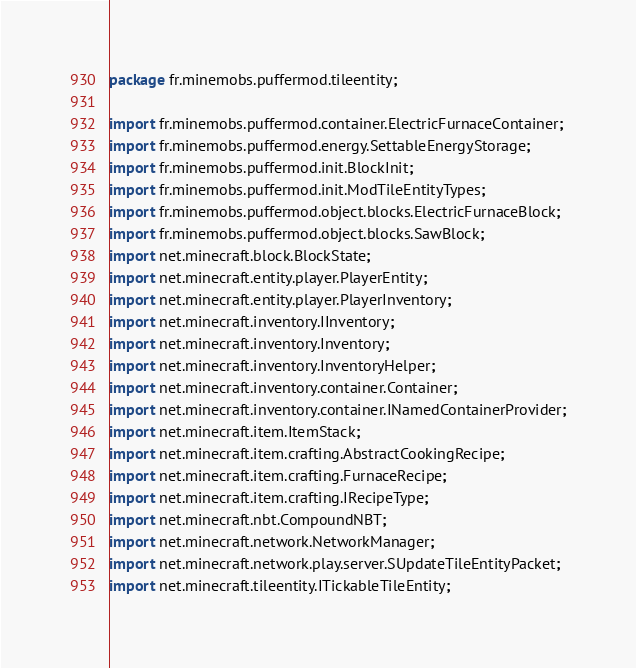<code> <loc_0><loc_0><loc_500><loc_500><_Java_>package fr.minemobs.puffermod.tileentity;

import fr.minemobs.puffermod.container.ElectricFurnaceContainer;
import fr.minemobs.puffermod.energy.SettableEnergyStorage;
import fr.minemobs.puffermod.init.BlockInit;
import fr.minemobs.puffermod.init.ModTileEntityTypes;
import fr.minemobs.puffermod.object.blocks.ElectricFurnaceBlock;
import fr.minemobs.puffermod.object.blocks.SawBlock;
import net.minecraft.block.BlockState;
import net.minecraft.entity.player.PlayerEntity;
import net.minecraft.entity.player.PlayerInventory;
import net.minecraft.inventory.IInventory;
import net.minecraft.inventory.Inventory;
import net.minecraft.inventory.InventoryHelper;
import net.minecraft.inventory.container.Container;
import net.minecraft.inventory.container.INamedContainerProvider;
import net.minecraft.item.ItemStack;
import net.minecraft.item.crafting.AbstractCookingRecipe;
import net.minecraft.item.crafting.FurnaceRecipe;
import net.minecraft.item.crafting.IRecipeType;
import net.minecraft.nbt.CompoundNBT;
import net.minecraft.network.NetworkManager;
import net.minecraft.network.play.server.SUpdateTileEntityPacket;
import net.minecraft.tileentity.ITickableTileEntity;</code> 